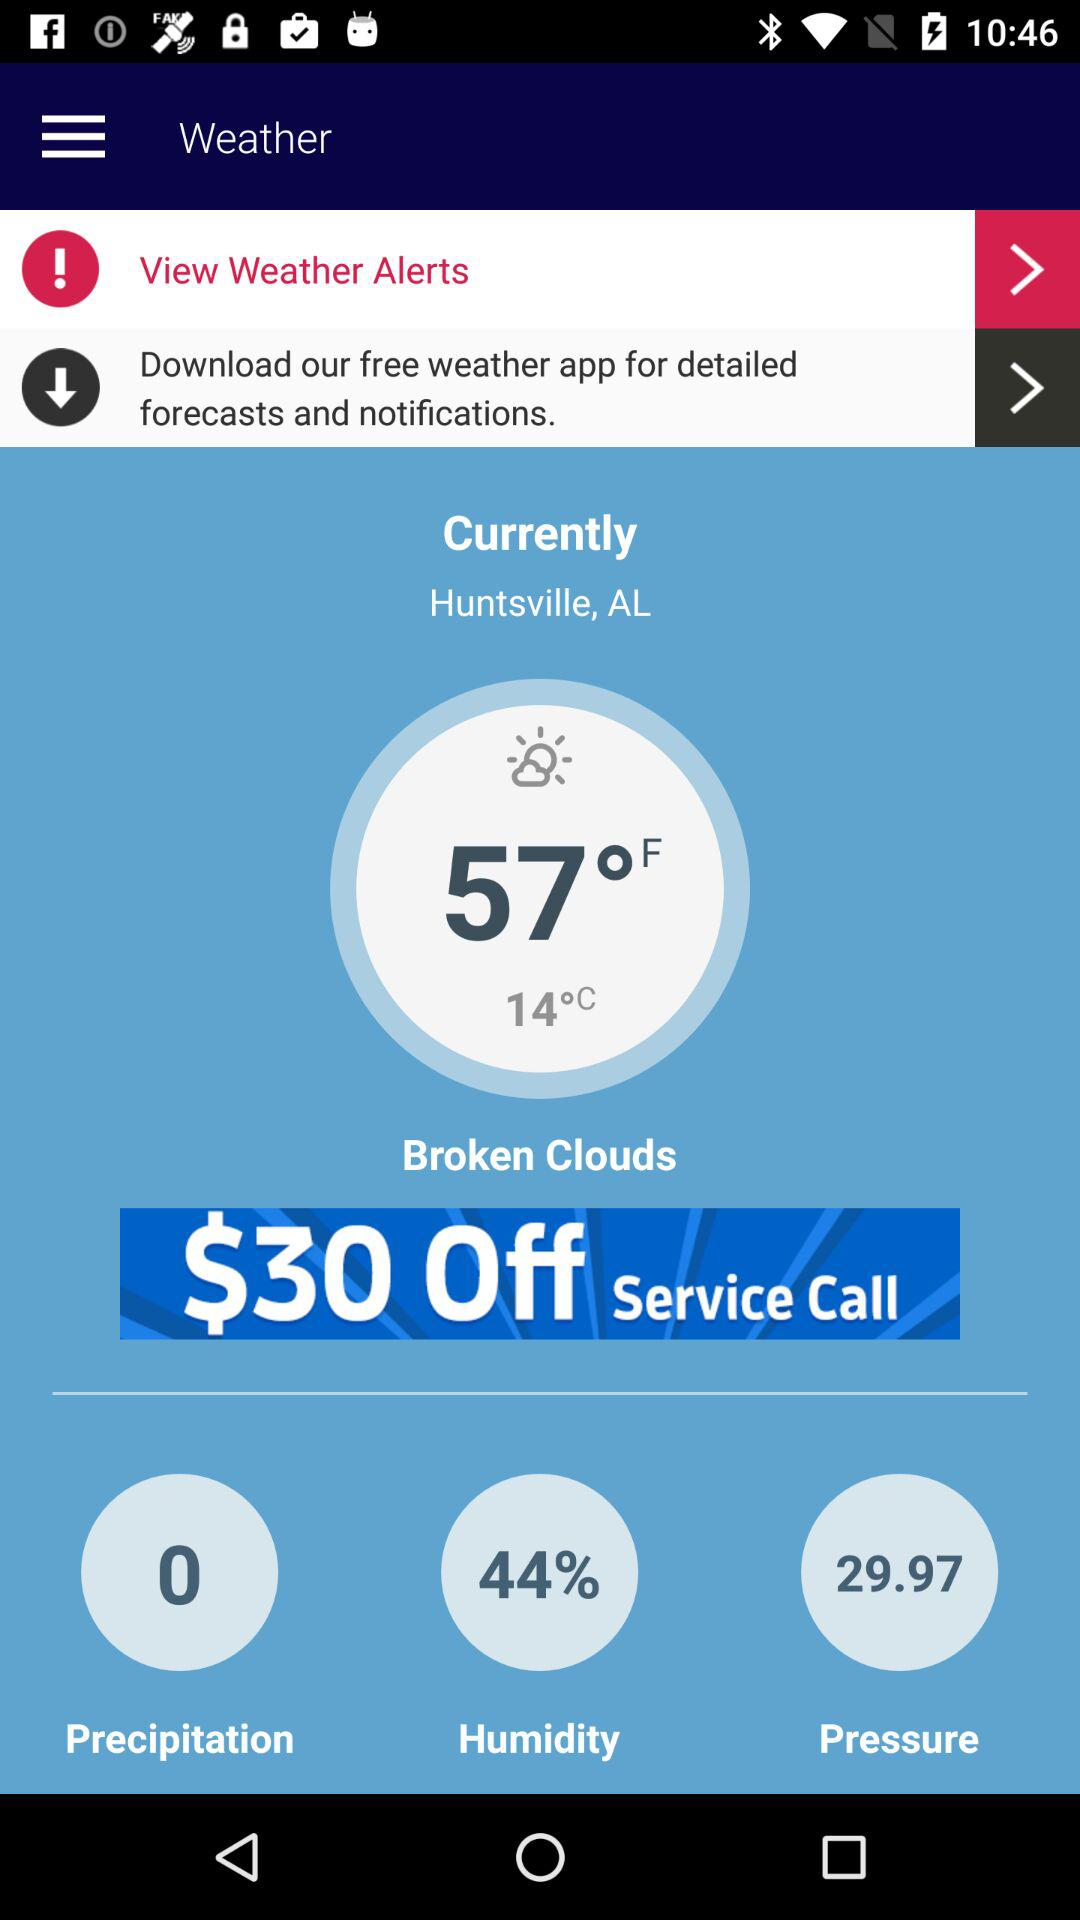What is the pressure? The pressure is 29.97. 